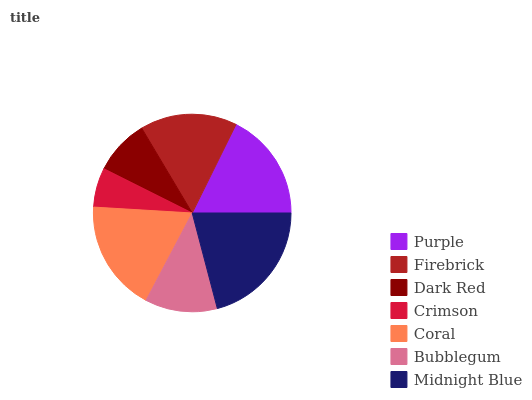Is Crimson the minimum?
Answer yes or no. Yes. Is Midnight Blue the maximum?
Answer yes or no. Yes. Is Firebrick the minimum?
Answer yes or no. No. Is Firebrick the maximum?
Answer yes or no. No. Is Purple greater than Firebrick?
Answer yes or no. Yes. Is Firebrick less than Purple?
Answer yes or no. Yes. Is Firebrick greater than Purple?
Answer yes or no. No. Is Purple less than Firebrick?
Answer yes or no. No. Is Firebrick the high median?
Answer yes or no. Yes. Is Firebrick the low median?
Answer yes or no. Yes. Is Coral the high median?
Answer yes or no. No. Is Purple the low median?
Answer yes or no. No. 